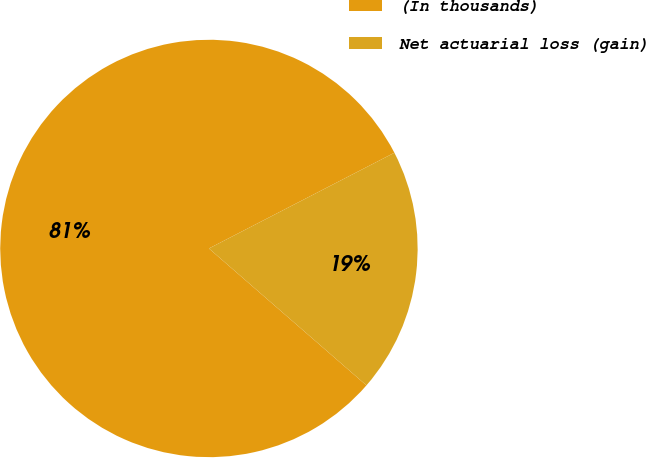<chart> <loc_0><loc_0><loc_500><loc_500><pie_chart><fcel>(In thousands)<fcel>Net actuarial loss (gain)<nl><fcel>81.03%<fcel>18.97%<nl></chart> 